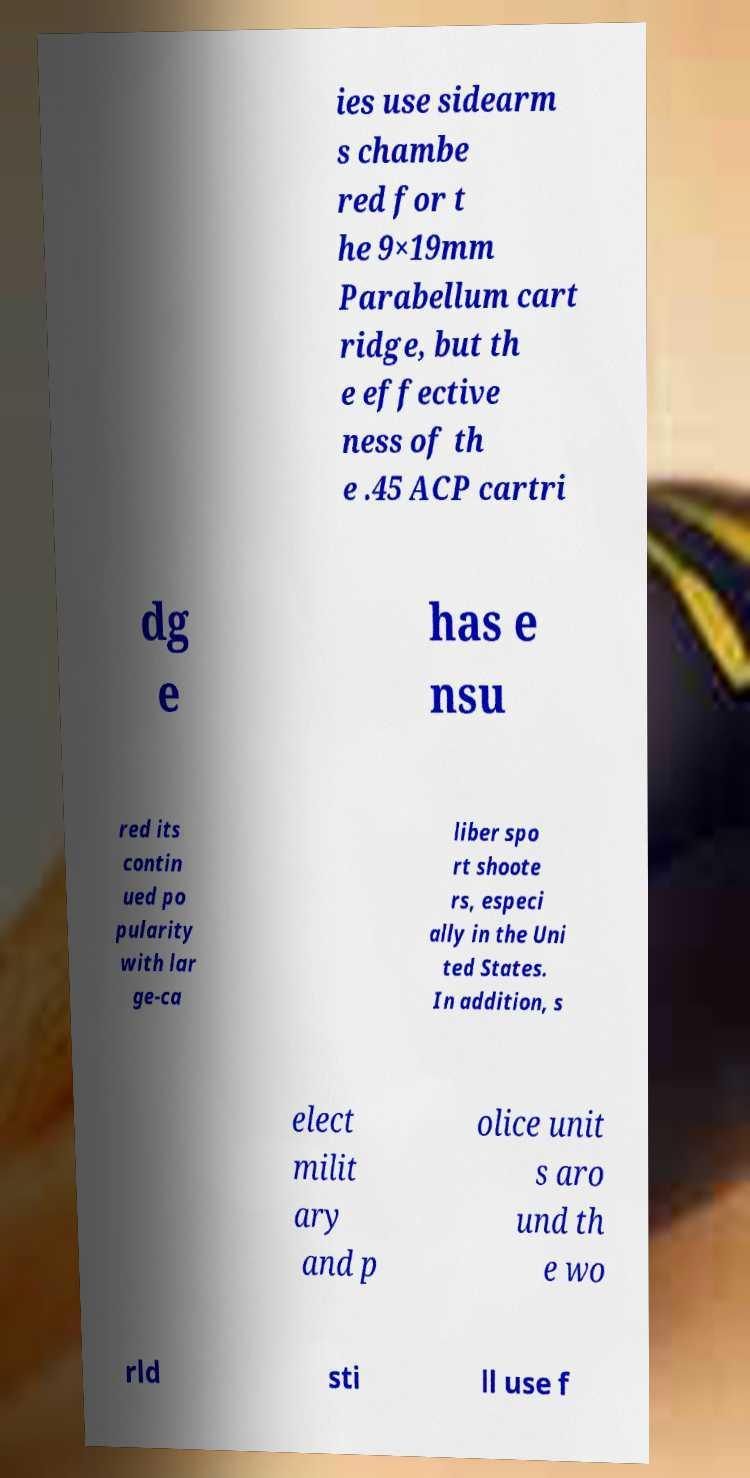Can you read and provide the text displayed in the image?This photo seems to have some interesting text. Can you extract and type it out for me? ies use sidearm s chambe red for t he 9×19mm Parabellum cart ridge, but th e effective ness of th e .45 ACP cartri dg e has e nsu red its contin ued po pularity with lar ge-ca liber spo rt shoote rs, especi ally in the Uni ted States. In addition, s elect milit ary and p olice unit s aro und th e wo rld sti ll use f 